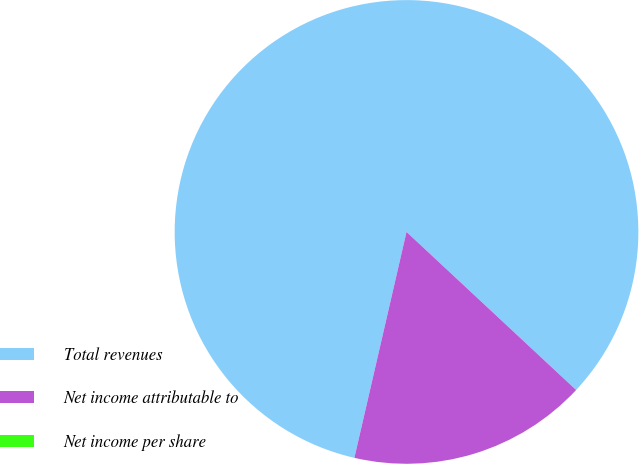Convert chart. <chart><loc_0><loc_0><loc_500><loc_500><pie_chart><fcel>Total revenues<fcel>Net income attributable to<fcel>Net income per share<nl><fcel>83.33%<fcel>16.67%<fcel>0.0%<nl></chart> 